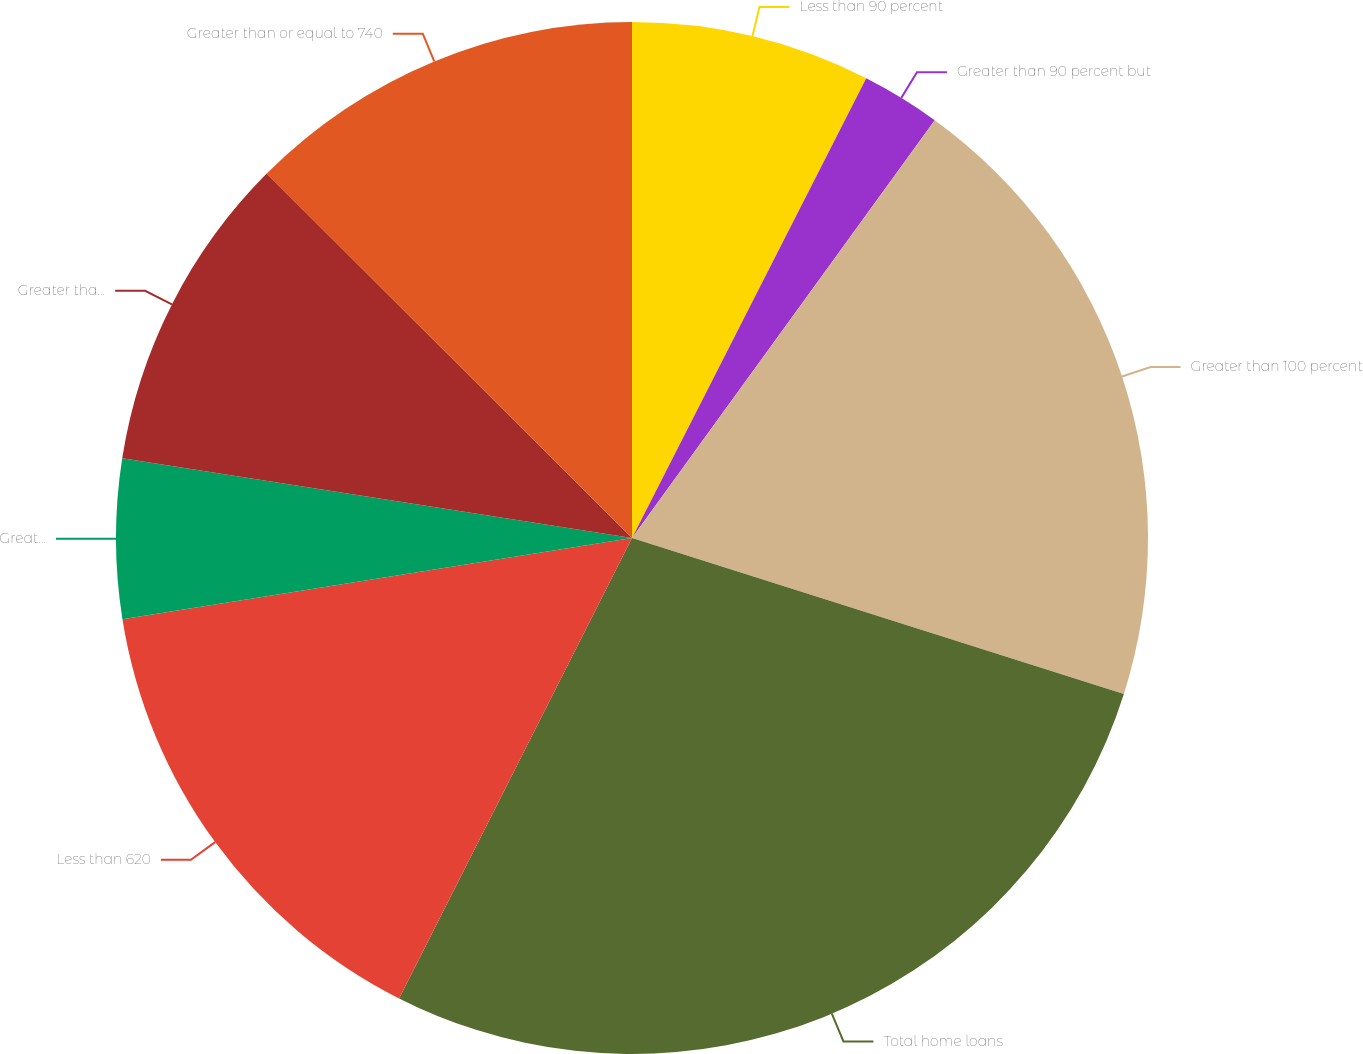<chart> <loc_0><loc_0><loc_500><loc_500><pie_chart><fcel>Less than 90 percent<fcel>Greater than 90 percent but<fcel>Greater than 100 percent<fcel>Total home loans<fcel>Less than 620<fcel>Greater than or equal to 620<fcel>Greater than or equal to 680<fcel>Greater than or equal to 740<nl><fcel>7.5%<fcel>2.48%<fcel>19.91%<fcel>27.57%<fcel>15.03%<fcel>4.99%<fcel>10.01%<fcel>12.52%<nl></chart> 